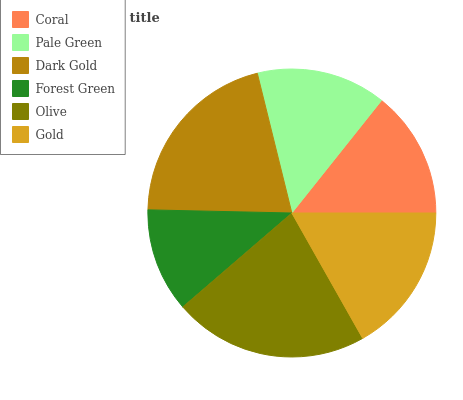Is Forest Green the minimum?
Answer yes or no. Yes. Is Olive the maximum?
Answer yes or no. Yes. Is Pale Green the minimum?
Answer yes or no. No. Is Pale Green the maximum?
Answer yes or no. No. Is Pale Green greater than Coral?
Answer yes or no. Yes. Is Coral less than Pale Green?
Answer yes or no. Yes. Is Coral greater than Pale Green?
Answer yes or no. No. Is Pale Green less than Coral?
Answer yes or no. No. Is Gold the high median?
Answer yes or no. Yes. Is Pale Green the low median?
Answer yes or no. Yes. Is Olive the high median?
Answer yes or no. No. Is Olive the low median?
Answer yes or no. No. 